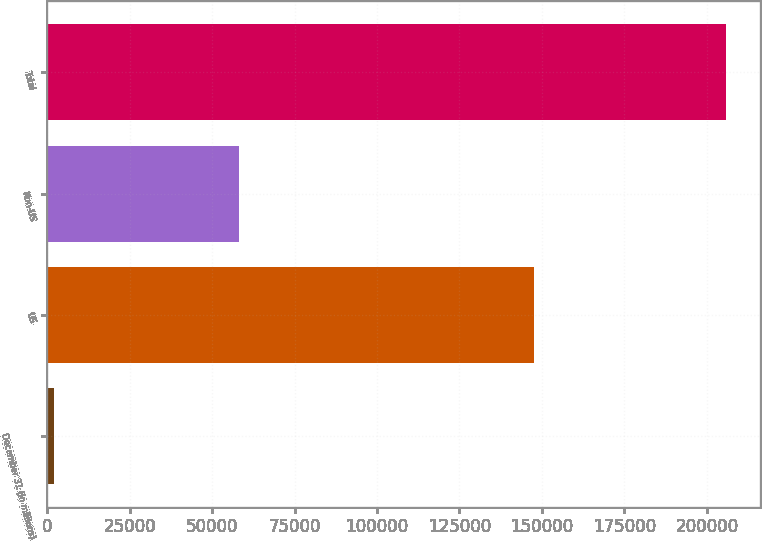<chart> <loc_0><loc_0><loc_500><loc_500><bar_chart><fcel>December 31 (in millions)<fcel>US<fcel>Non-US<fcel>Total<nl><fcel>2008<fcel>147493<fcel>58247<fcel>205740<nl></chart> 